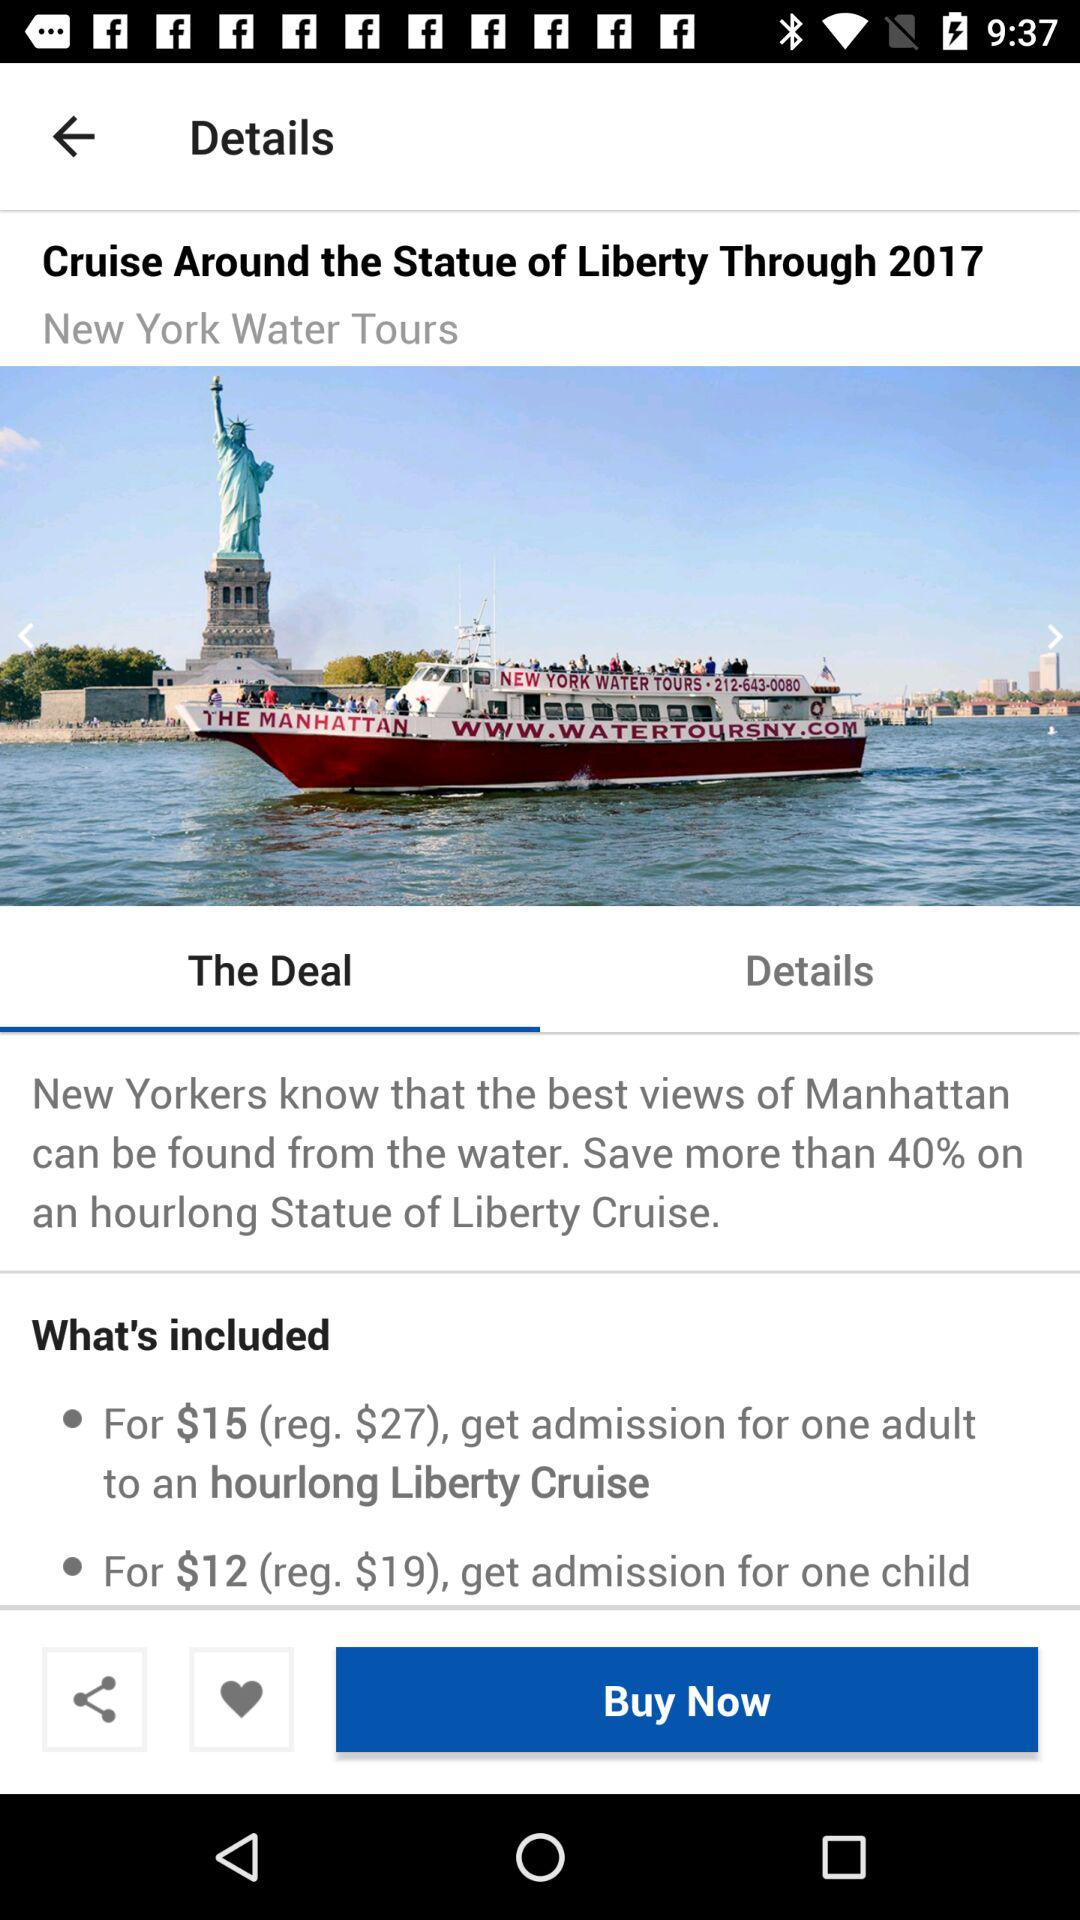What is the application name? The application name is "TRAVELZOO". 